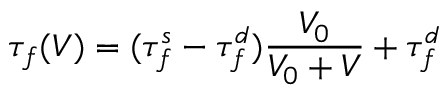<formula> <loc_0><loc_0><loc_500><loc_500>\tau _ { f } ( V ) = ( \tau _ { f } ^ { s } - \tau _ { f } ^ { d } ) \frac { V _ { 0 } } { V _ { 0 } + V } + \tau _ { f } ^ { d }</formula> 